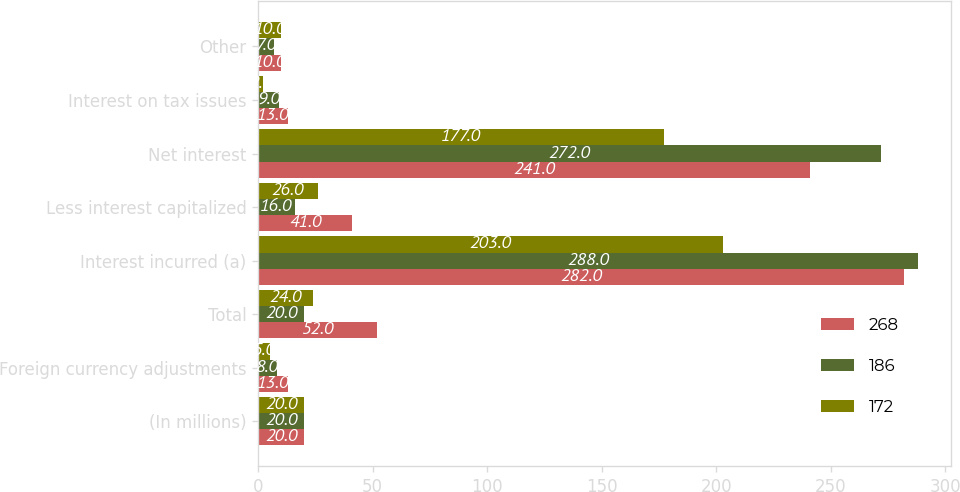Convert chart to OTSL. <chart><loc_0><loc_0><loc_500><loc_500><stacked_bar_chart><ecel><fcel>(In millions)<fcel>Foreign currency adjustments<fcel>Total<fcel>Interest incurred (a)<fcel>Less interest capitalized<fcel>Net interest<fcel>Interest on tax issues<fcel>Other<nl><fcel>268<fcel>20<fcel>13<fcel>52<fcel>282<fcel>41<fcel>241<fcel>13<fcel>10<nl><fcel>186<fcel>20<fcel>8<fcel>20<fcel>288<fcel>16<fcel>272<fcel>9<fcel>7<nl><fcel>172<fcel>20<fcel>5<fcel>24<fcel>203<fcel>26<fcel>177<fcel>2<fcel>10<nl></chart> 